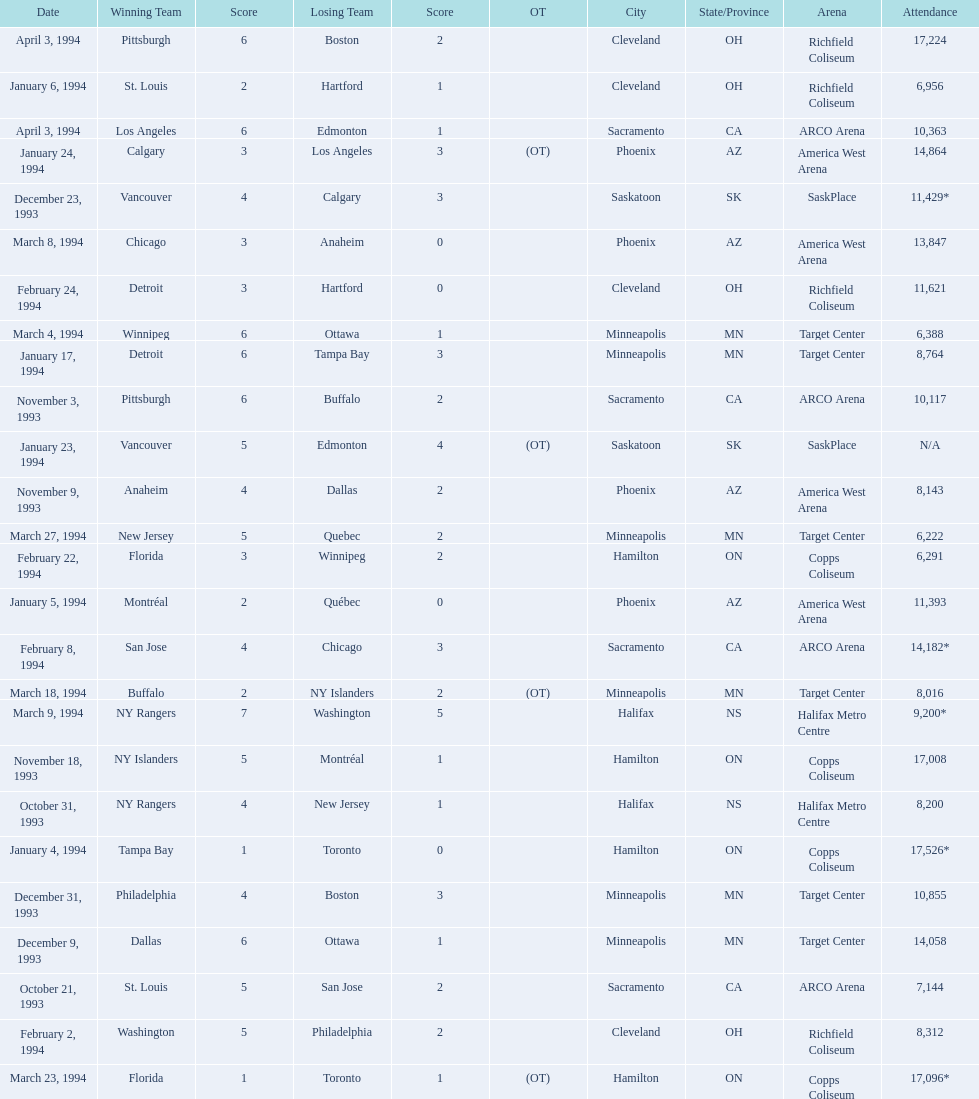When were the games played? October 21, 1993, October 31, 1993, November 3, 1993, November 9, 1993, November 18, 1993, December 9, 1993, December 23, 1993, December 31, 1993, January 4, 1994, January 5, 1994, January 6, 1994, January 17, 1994, January 23, 1994, January 24, 1994, February 2, 1994, February 8, 1994, February 22, 1994, February 24, 1994, March 4, 1994, March 8, 1994, March 9, 1994, March 18, 1994, March 23, 1994, March 27, 1994, April 3, 1994, April 3, 1994. What was the attendance for those games? 7,144, 8,200, 10,117, 8,143, 17,008, 14,058, 11,429*, 10,855, 17,526*, 11,393, 6,956, 8,764, N/A, 14,864, 8,312, 14,182*, 6,291, 11,621, 6,388, 13,847, 9,200*, 8,016, 17,096*, 6,222, 17,224, 10,363. Which date had the highest attendance? January 4, 1994. 